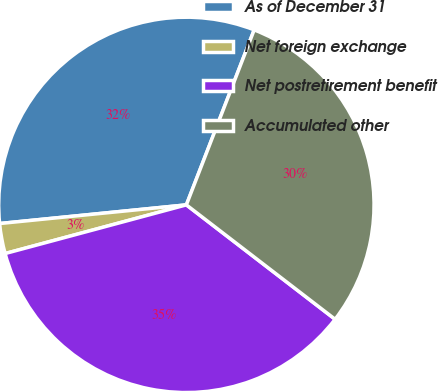Convert chart to OTSL. <chart><loc_0><loc_0><loc_500><loc_500><pie_chart><fcel>As of December 31<fcel>Net foreign exchange<fcel>Net postretirement benefit<fcel>Accumulated other<nl><fcel>32.47%<fcel>2.59%<fcel>35.39%<fcel>29.55%<nl></chart> 